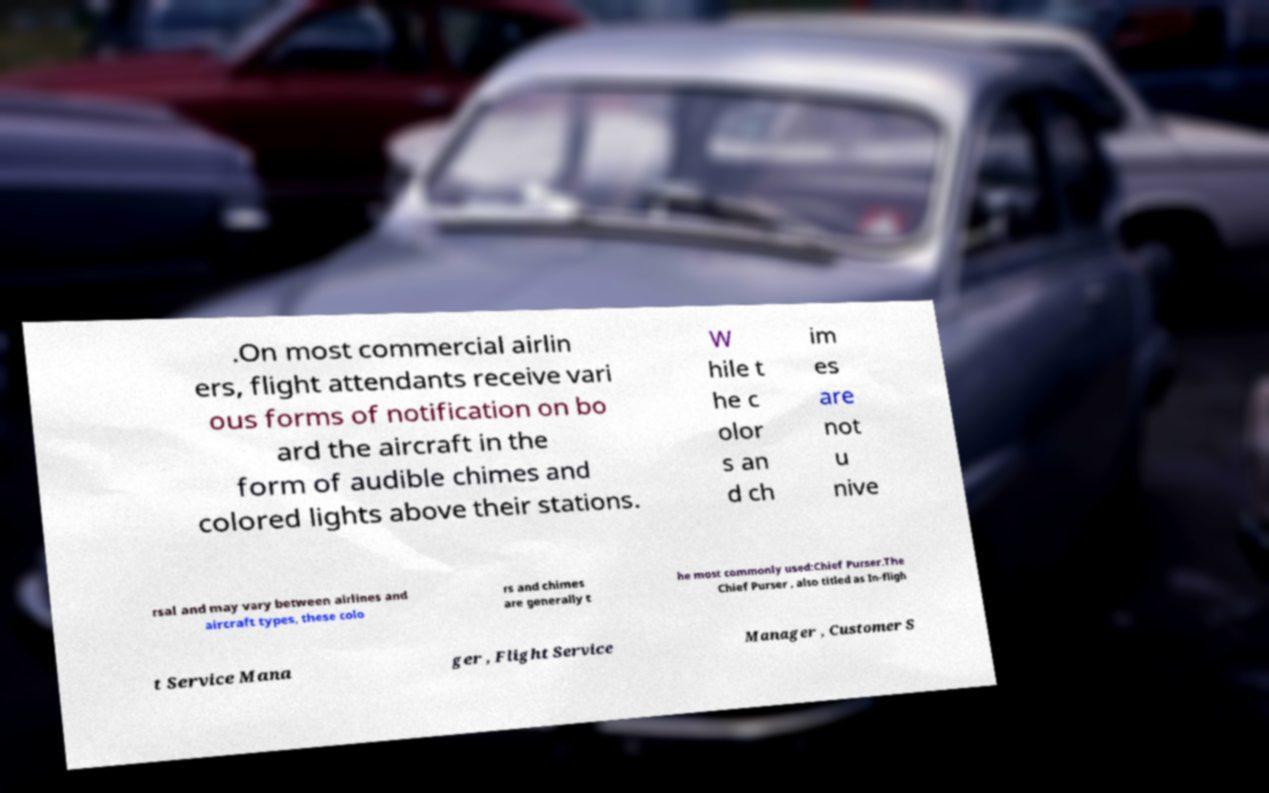I need the written content from this picture converted into text. Can you do that? .On most commercial airlin ers, flight attendants receive vari ous forms of notification on bo ard the aircraft in the form of audible chimes and colored lights above their stations. W hile t he c olor s an d ch im es are not u nive rsal and may vary between airlines and aircraft types, these colo rs and chimes are generally t he most commonly used:Chief Purser.The Chief Purser , also titled as In-fligh t Service Mana ger , Flight Service Manager , Customer S 